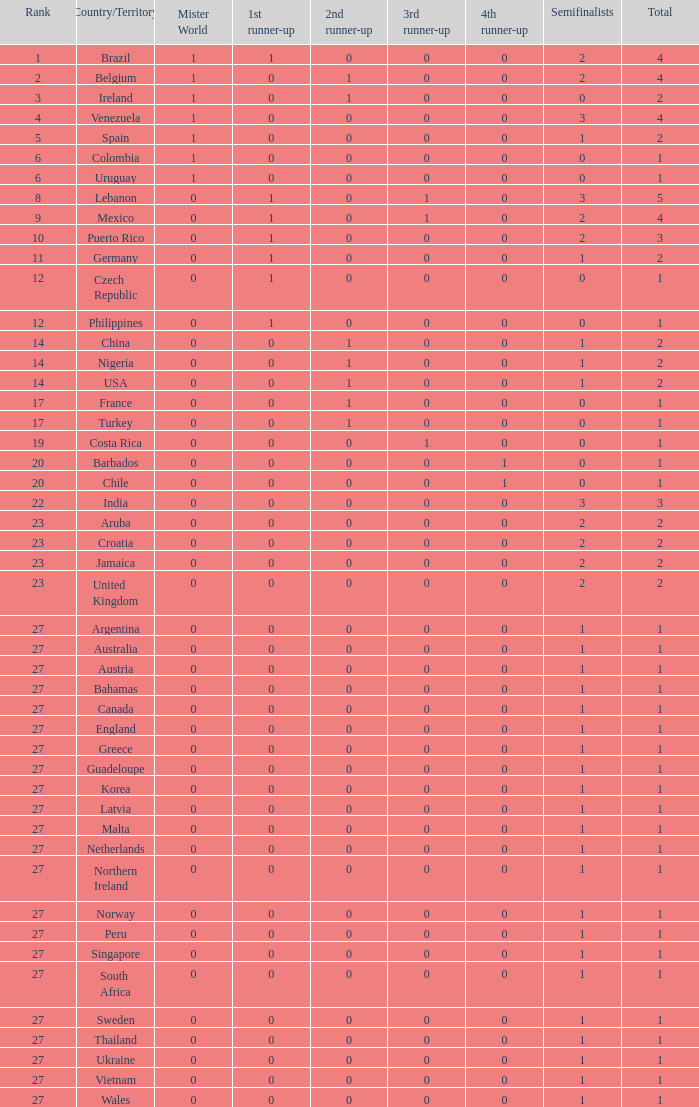What is the number of 1st runner up values for Jamaica? 1.0. 